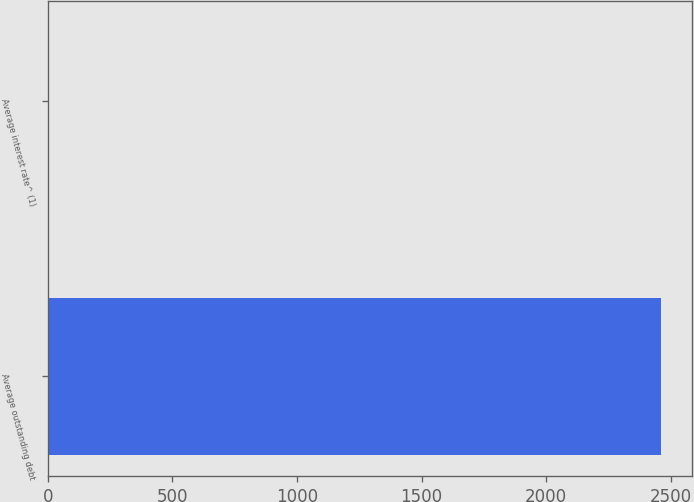Convert chart to OTSL. <chart><loc_0><loc_0><loc_500><loc_500><bar_chart><fcel>Average outstanding debt<fcel>Average interest rate^ (1)<nl><fcel>2461<fcel>4.8<nl></chart> 